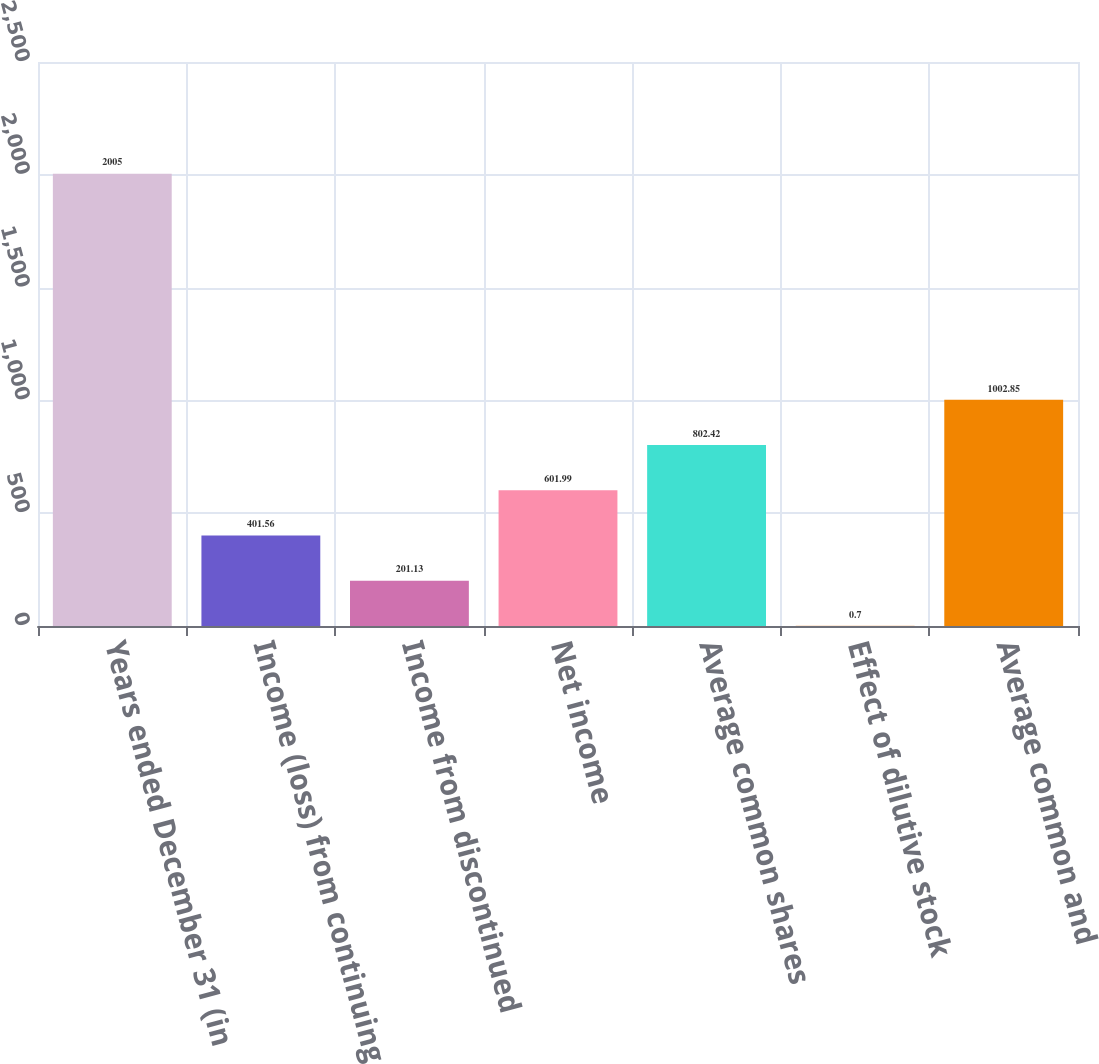Convert chart. <chart><loc_0><loc_0><loc_500><loc_500><bar_chart><fcel>Years ended December 31 (in<fcel>Income (loss) from continuing<fcel>Income from discontinued<fcel>Net income<fcel>Average common shares<fcel>Effect of dilutive stock<fcel>Average common and<nl><fcel>2005<fcel>401.56<fcel>201.13<fcel>601.99<fcel>802.42<fcel>0.7<fcel>1002.85<nl></chart> 